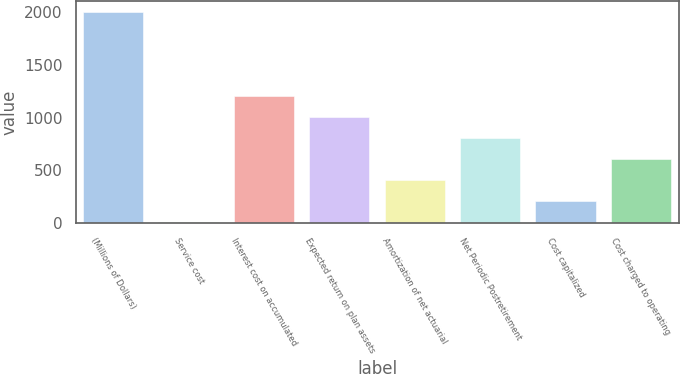<chart> <loc_0><loc_0><loc_500><loc_500><bar_chart><fcel>(Millions of Dollars)<fcel>Service cost<fcel>Interest cost on accumulated<fcel>Expected return on plan assets<fcel>Amortization of net actuarial<fcel>Net Periodic Postretirement<fcel>Cost capitalized<fcel>Cost charged to operating<nl><fcel>2002<fcel>10<fcel>1205.2<fcel>1006<fcel>408.4<fcel>806.8<fcel>209.2<fcel>607.6<nl></chart> 